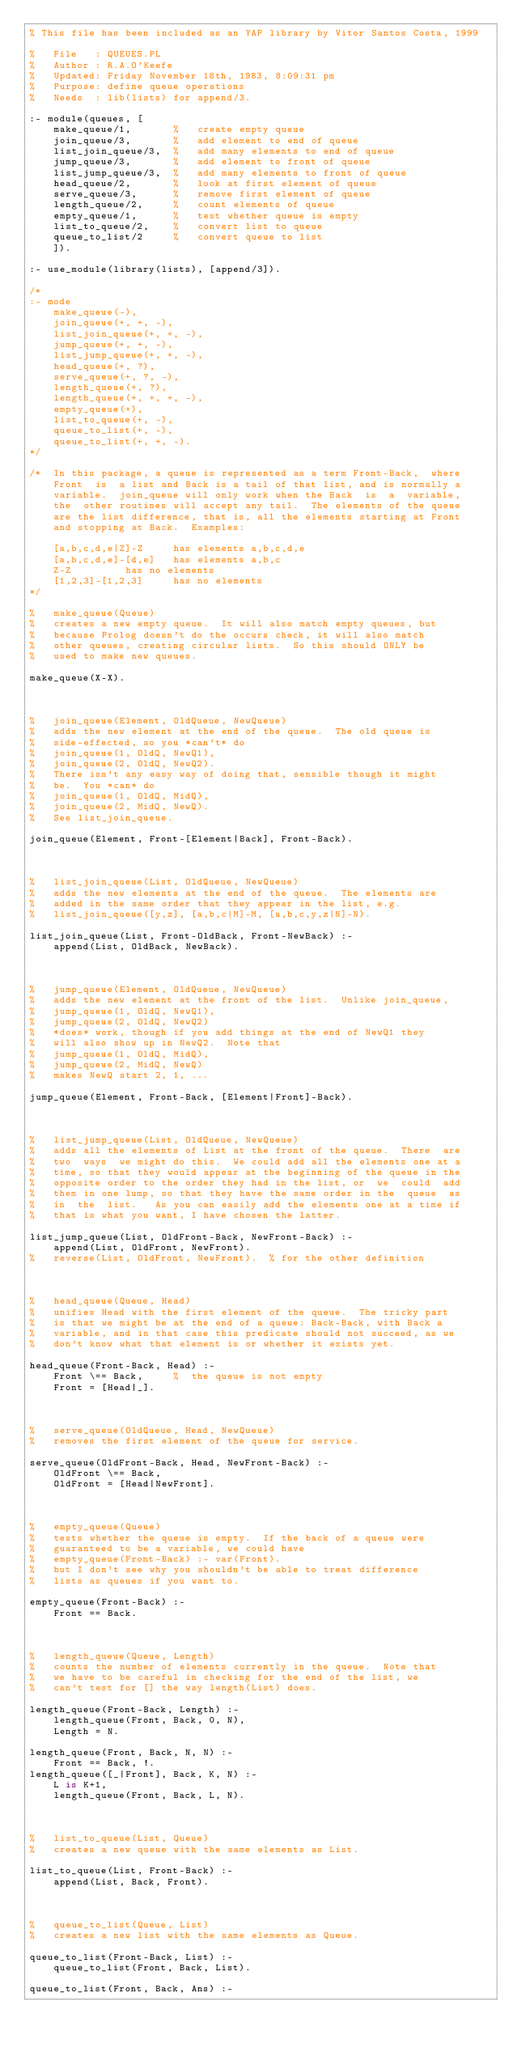Convert code to text. <code><loc_0><loc_0><loc_500><loc_500><_Prolog_>% This file has been included as an YAP library by Vitor Santos Costa, 1999

%   File   : QUEUES.PL
%   Author : R.A.O'Keefe
%   Updated: Friday November 18th, 1983, 8:09:31 pm
%   Purpose: define queue operations
%   Needs  : lib(lists) for append/3.

:- module(queues, [
	make_queue/1,		%   create empty queue
	join_queue/3,		%   add element to end of queue
	list_join_queue/3,	%   add many elements to end of queue
	jump_queue/3,		%   add element to front of queue
	list_jump_queue/3,	%   add many elements to front of queue
	head_queue/2,		%   look at first element of queue
	serve_queue/3,		%   remove first element of queue
	length_queue/2,		%   count elements of queue
	empty_queue/1,		%   test whether queue is empty
	list_to_queue/2,	%   convert list to queue
	queue_to_list/2		%   convert queue to list
    ]).

:- use_module(library(lists), [append/3]).

/*
:- mode
	make_queue(-),
	join_queue(+, +, -),
	list_join_queue(+, +, -),
	jump_queue(+, +, -),
	list_jump_queue(+, +, -),
	head_queue(+, ?),
	serve_queue(+, ?, -),
	length_queue(+, ?),
	length_queue(+, +, +, -),
	empty_queue(+),
	list_to_queue(+, -),
	queue_to_list(+, -),
	queue_to_list(+, +, -).
*/

/*  In this package, a queue is represented as a term Front-Back,  where
    Front  is  a list and Back is a tail of that list, and is normally a
    variable.  join_queue will only work when the Back  is  a  variable,
    the  other routines will accept any tail.  The elements of the queue
    are the list difference, that is, all the elements starting at Front
    and stopping at Back.  Examples:

	[a,b,c,d,e|Z]-Z	    has elements a,b,c,d,e
	[a,b,c,d,e]-[d,e]   has elements a,b,c
	Z-Z		    has no elements
	[1,2,3]-[1,2,3]	    has no elements
*/

%   make_queue(Queue)
%   creates a new empty queue.  It will also match empty queues, but
%   because Prolog doesn't do the occurs check, it will also match
%   other queues, creating circular lists.  So this should ONLY be
%   used to make new queues.

make_queue(X-X).



%   join_queue(Element, OldQueue, NewQueue)
%   adds the new element at the end of the queue.  The old queue is
%   side-effected, so you *can't* do
%	join_queue(1, OldQ, NewQ1),
%	join_queue(2, OldQ, NewQ2).
%   There isn't any easy way of doing that, sensible though it might
%   be.  You *can* do
%	join_queue(1, OldQ, MidQ),
%	join_queue(2, MidQ, NewQ).
%   See list_join_queue.

join_queue(Element, Front-[Element|Back], Front-Back).



%   list_join_queue(List, OldQueue, NewQueue)
%   adds the new elements at the end of the queue.  The elements are
%   added in the same order that they appear in the list, e.g.
%   list_join_queue([y,z], [a,b,c|M]-M, [a,b,c,y,z|N]-N).

list_join_queue(List, Front-OldBack, Front-NewBack) :-
	append(List, OldBack, NewBack).



%   jump_queue(Element, OldQueue, NewQueue)
%   adds the new element at the front of the list.  Unlike join_queue,
%	jump_queue(1, OldQ, NewQ1),
%	jump_queue(2, OldQ, NewQ2)
%   *does* work, though if you add things at the end of NewQ1 they
%   will also show up in NewQ2.  Note that
%	jump_queue(1, OldQ, MidQ),
%	jump_queue(2, MidQ, NewQ)
%   makes NewQ start 2, 1, ...

jump_queue(Element, Front-Back, [Element|Front]-Back).



%   list_jump_queue(List, OldQueue, NewQueue)
%   adds all the elements of List at the front of the queue.  There  are
%   two  ways  we might do this.  We could add all the elements one at a
%   time, so that they would appear at the beginning of the queue in the
%   opposite order to the order they had in the list, or  we  could  add
%   them in one lump, so that they have the same order in the  queue  as
%   in  the  list.   As you can easily add the elements one at a time if
%   that is what you want, I have chosen the latter.

list_jump_queue(List, OldFront-Back, NewFront-Back) :-
	append(List, OldFront, NewFront).
%	reverse(List, OldFront, NewFront).	% for the other definition



%   head_queue(Queue, Head)
%   unifies Head with the first element of the queue.  The tricky part
%   is that we might be at the end of a queue: Back-Back, with Back a
%   variable, and in that case this predicate should not succeed, as we
%   don't know what that element is or whether it exists yet.

head_queue(Front-Back, Head) :-
	Front \== Back,		%  the queue is not empty
	Front = [Head|_].



%   serve_queue(OldQueue, Head, NewQueue)
%   removes the first element of the queue for service.

serve_queue(OldFront-Back, Head, NewFront-Back) :-
	OldFront \== Back,
	OldFront = [Head|NewFront].



%   empty_queue(Queue)
%   tests whether the queue is empty.  If the back of a queue were
%   guaranteed to be a variable, we could have
%	empty_queue(Front-Back) :- var(Front).
%   but I don't see why you shouldn't be able to treat difference
%   lists as queues if you want to.

empty_queue(Front-Back) :-
	Front == Back.



%   length_queue(Queue, Length)
%   counts the number of elements currently in the queue.  Note that
%   we have to be careful in checking for the end of the list, we
%   can't test for [] the way length(List) does.

length_queue(Front-Back, Length) :-
	length_queue(Front, Back, 0, N),
	Length = N.

length_queue(Front, Back, N, N) :-
	Front == Back, !.
length_queue([_|Front], Back, K, N) :-
	L is K+1,
	length_queue(Front, Back, L, N).



%   list_to_queue(List, Queue)
%   creates a new queue with the same elements as List.

list_to_queue(List, Front-Back) :-
	append(List, Back, Front).



%   queue_to_list(Queue, List)
%   creates a new list with the same elements as Queue.

queue_to_list(Front-Back, List) :-
	queue_to_list(Front, Back, List).

queue_to_list(Front, Back, Ans) :-</code> 